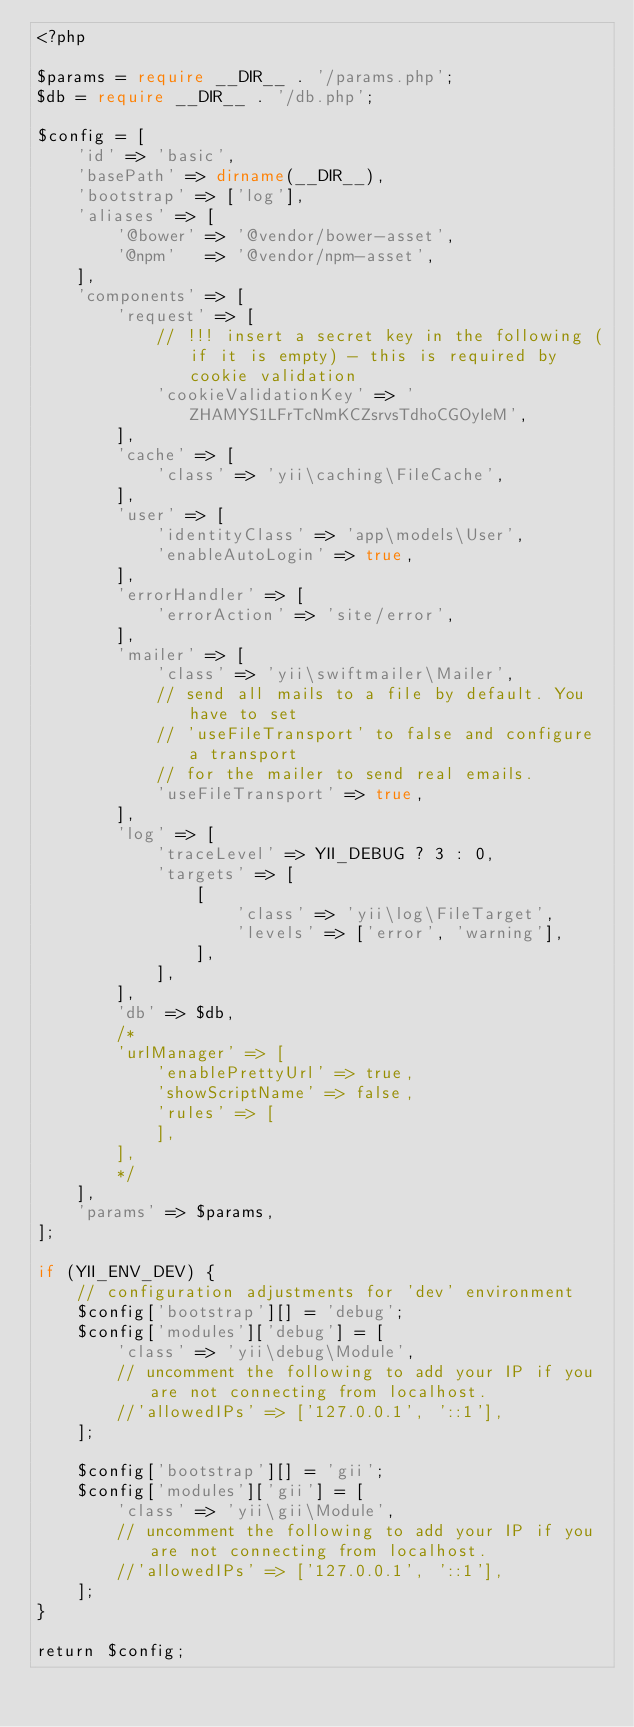<code> <loc_0><loc_0><loc_500><loc_500><_PHP_><?php

$params = require __DIR__ . '/params.php';
$db = require __DIR__ . '/db.php';

$config = [
    'id' => 'basic',
    'basePath' => dirname(__DIR__),
    'bootstrap' => ['log'],
    'aliases' => [
        '@bower' => '@vendor/bower-asset',
        '@npm'   => '@vendor/npm-asset',
    ],
    'components' => [
        'request' => [
            // !!! insert a secret key in the following (if it is empty) - this is required by cookie validation
            'cookieValidationKey' => 'ZHAMYS1LFrTcNmKCZsrvsTdhoCGOyIeM',
        ],
        'cache' => [
            'class' => 'yii\caching\FileCache',
        ],
        'user' => [
            'identityClass' => 'app\models\User',
            'enableAutoLogin' => true,
        ],
        'errorHandler' => [
            'errorAction' => 'site/error',
        ],
        'mailer' => [
            'class' => 'yii\swiftmailer\Mailer',
            // send all mails to a file by default. You have to set
            // 'useFileTransport' to false and configure a transport
            // for the mailer to send real emails.
            'useFileTransport' => true,
        ],
        'log' => [
            'traceLevel' => YII_DEBUG ? 3 : 0,
            'targets' => [
                [
                    'class' => 'yii\log\FileTarget',
                    'levels' => ['error', 'warning'],
                ],
            ],
        ],
        'db' => $db,
        /*
        'urlManager' => [
            'enablePrettyUrl' => true,
            'showScriptName' => false,
            'rules' => [
            ],
        ],
        */
    ],
    'params' => $params,
];

if (YII_ENV_DEV) {
    // configuration adjustments for 'dev' environment
    $config['bootstrap'][] = 'debug';
    $config['modules']['debug'] = [
        'class' => 'yii\debug\Module',
        // uncomment the following to add your IP if you are not connecting from localhost.
        //'allowedIPs' => ['127.0.0.1', '::1'],
    ];

    $config['bootstrap'][] = 'gii';
    $config['modules']['gii'] = [
        'class' => 'yii\gii\Module',
        // uncomment the following to add your IP if you are not connecting from localhost.
        //'allowedIPs' => ['127.0.0.1', '::1'],
    ];
}

return $config;
</code> 